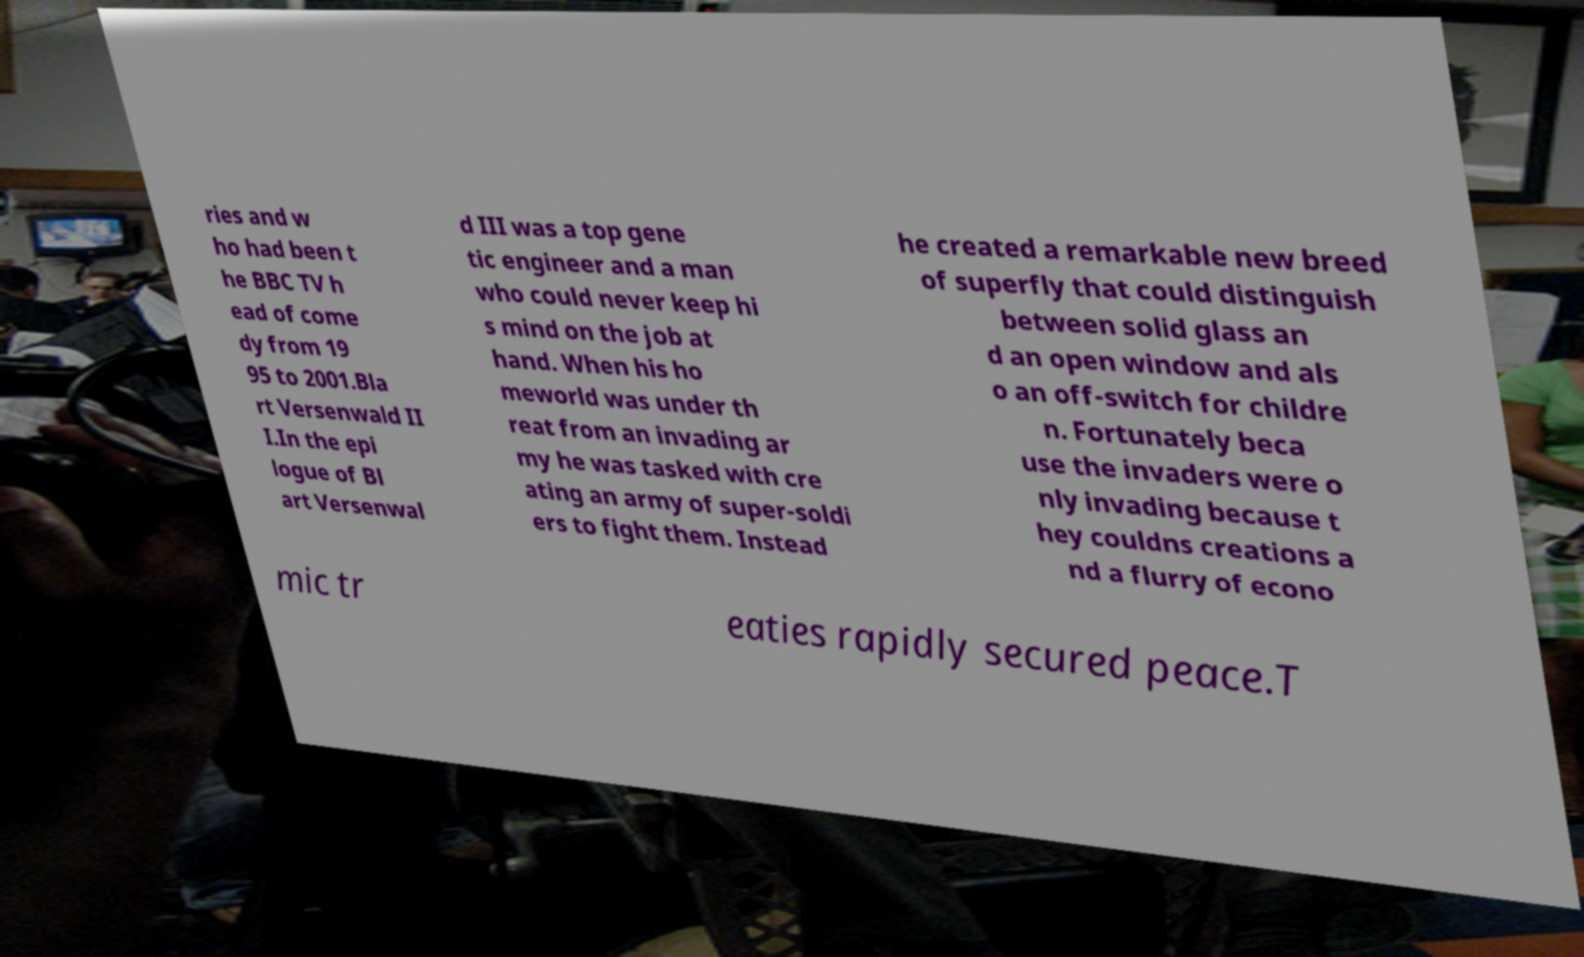What messages or text are displayed in this image? I need them in a readable, typed format. ries and w ho had been t he BBC TV h ead of come dy from 19 95 to 2001.Bla rt Versenwald II I.In the epi logue of Bl art Versenwal d III was a top gene tic engineer and a man who could never keep hi s mind on the job at hand. When his ho meworld was under th reat from an invading ar my he was tasked with cre ating an army of super-soldi ers to fight them. Instead he created a remarkable new breed of superfly that could distinguish between solid glass an d an open window and als o an off-switch for childre n. Fortunately beca use the invaders were o nly invading because t hey couldns creations a nd a flurry of econo mic tr eaties rapidly secured peace.T 